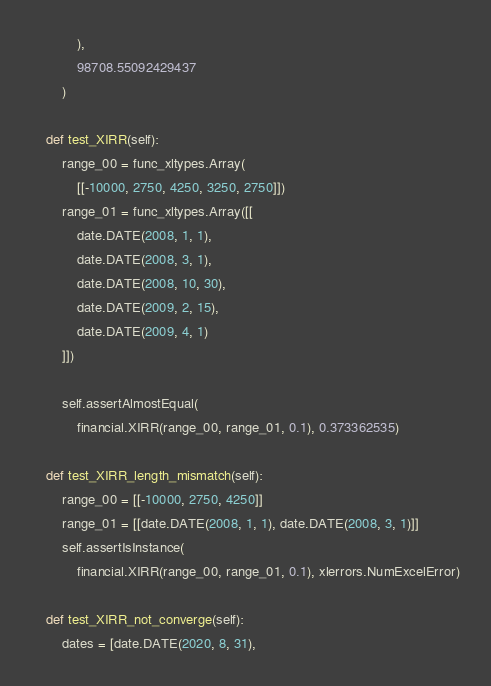Convert code to text. <code><loc_0><loc_0><loc_500><loc_500><_Python_>            ),
            98708.55092429437
        )

    def test_XIRR(self):
        range_00 = func_xltypes.Array(
            [[-10000, 2750, 4250, 3250, 2750]])
        range_01 = func_xltypes.Array([[
            date.DATE(2008, 1, 1),
            date.DATE(2008, 3, 1),
            date.DATE(2008, 10, 30),
            date.DATE(2009, 2, 15),
            date.DATE(2009, 4, 1)
        ]])

        self.assertAlmostEqual(
            financial.XIRR(range_00, range_01, 0.1), 0.373362535)

    def test_XIRR_length_mismatch(self):
        range_00 = [[-10000, 2750, 4250]]
        range_01 = [[date.DATE(2008, 1, 1), date.DATE(2008, 3, 1)]]
        self.assertIsInstance(
            financial.XIRR(range_00, range_01, 0.1), xlerrors.NumExcelError)

    def test_XIRR_not_converge(self):
        dates = [date.DATE(2020, 8, 31),</code> 